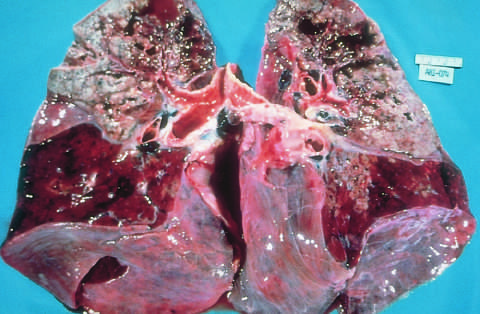re the upper parts of both lungs riddled with gray-white areas of caseation and multiple areas of softening and cavitation?
Answer the question using a single word or phrase. Yes 